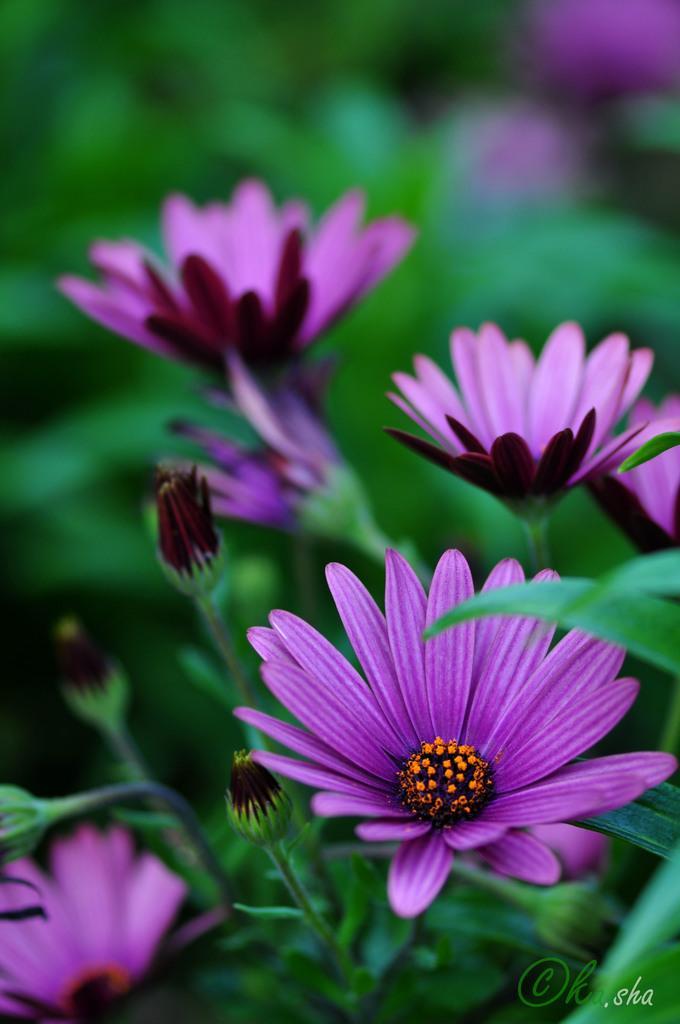Can you describe this image briefly? In this image I can see few flowers in purple color. In the background I can see few leaves in green color. 